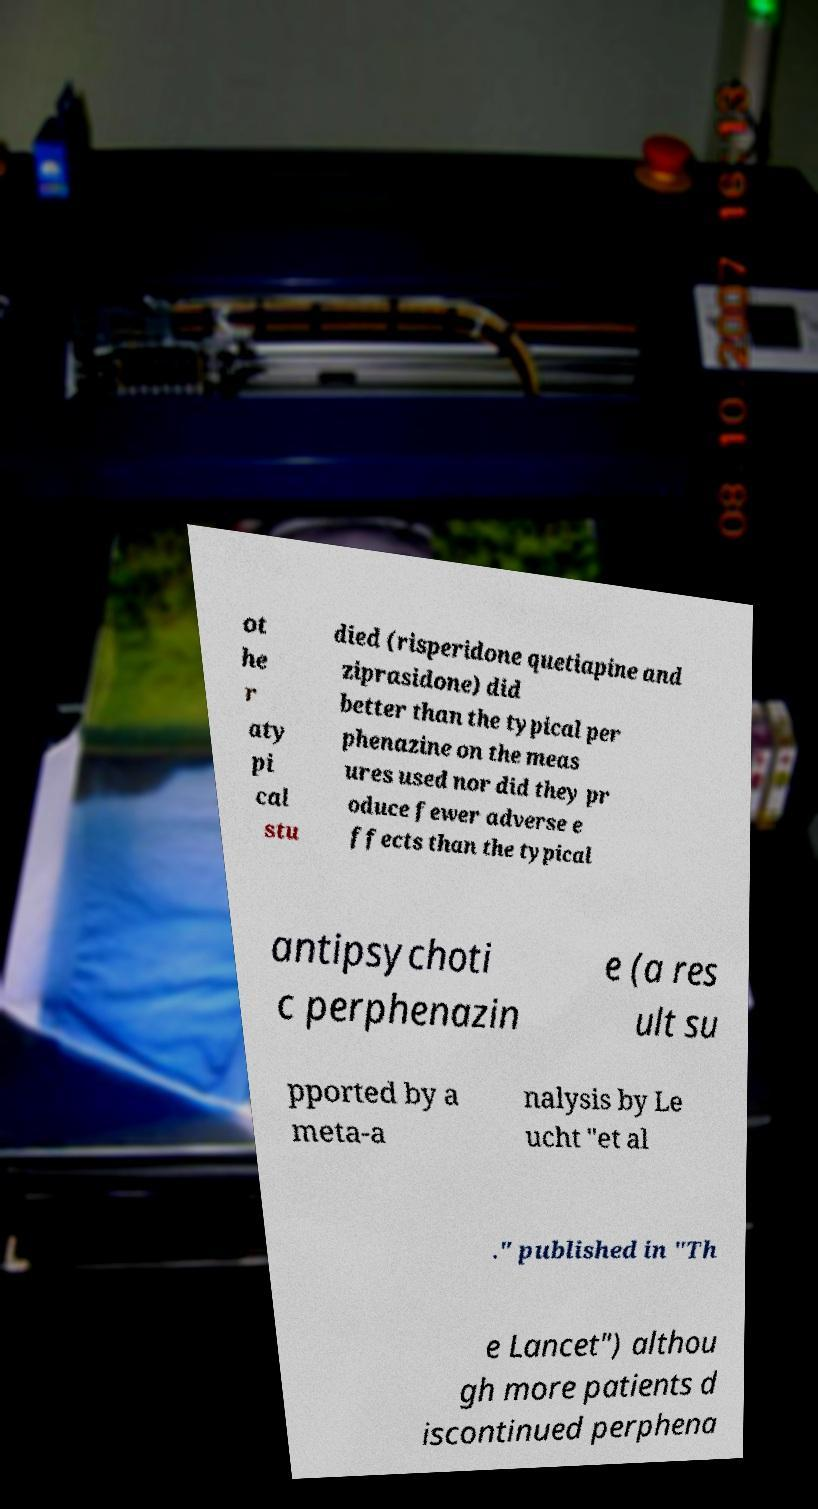Can you read and provide the text displayed in the image?This photo seems to have some interesting text. Can you extract and type it out for me? ot he r aty pi cal stu died (risperidone quetiapine and ziprasidone) did better than the typical per phenazine on the meas ures used nor did they pr oduce fewer adverse e ffects than the typical antipsychoti c perphenazin e (a res ult su pported by a meta-a nalysis by Le ucht "et al ." published in "Th e Lancet") althou gh more patients d iscontinued perphena 